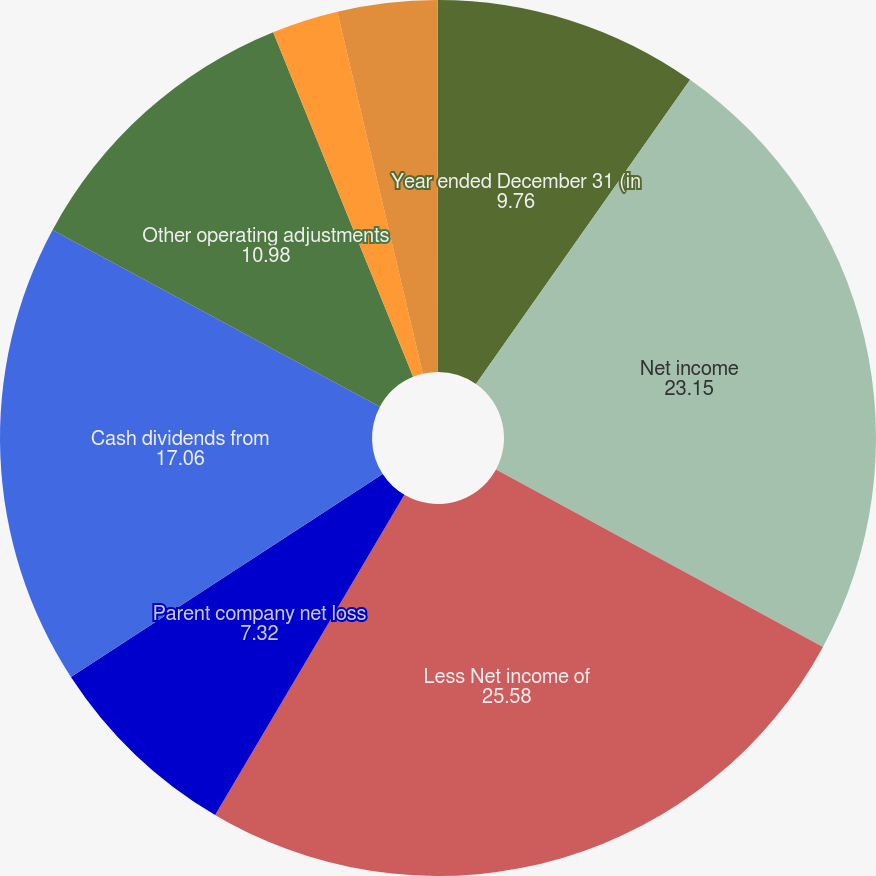<chart> <loc_0><loc_0><loc_500><loc_500><pie_chart><fcel>Year ended December 31 (in<fcel>Net income<fcel>Less Net income of<fcel>Parent company net loss<fcel>Cash dividends from<fcel>Other operating adjustments<fcel>Net cash provided by/(used in)<fcel>Advances to and investments in<fcel>All other investing activities<nl><fcel>9.76%<fcel>23.15%<fcel>25.58%<fcel>7.32%<fcel>17.06%<fcel>10.98%<fcel>2.45%<fcel>3.67%<fcel>0.02%<nl></chart> 